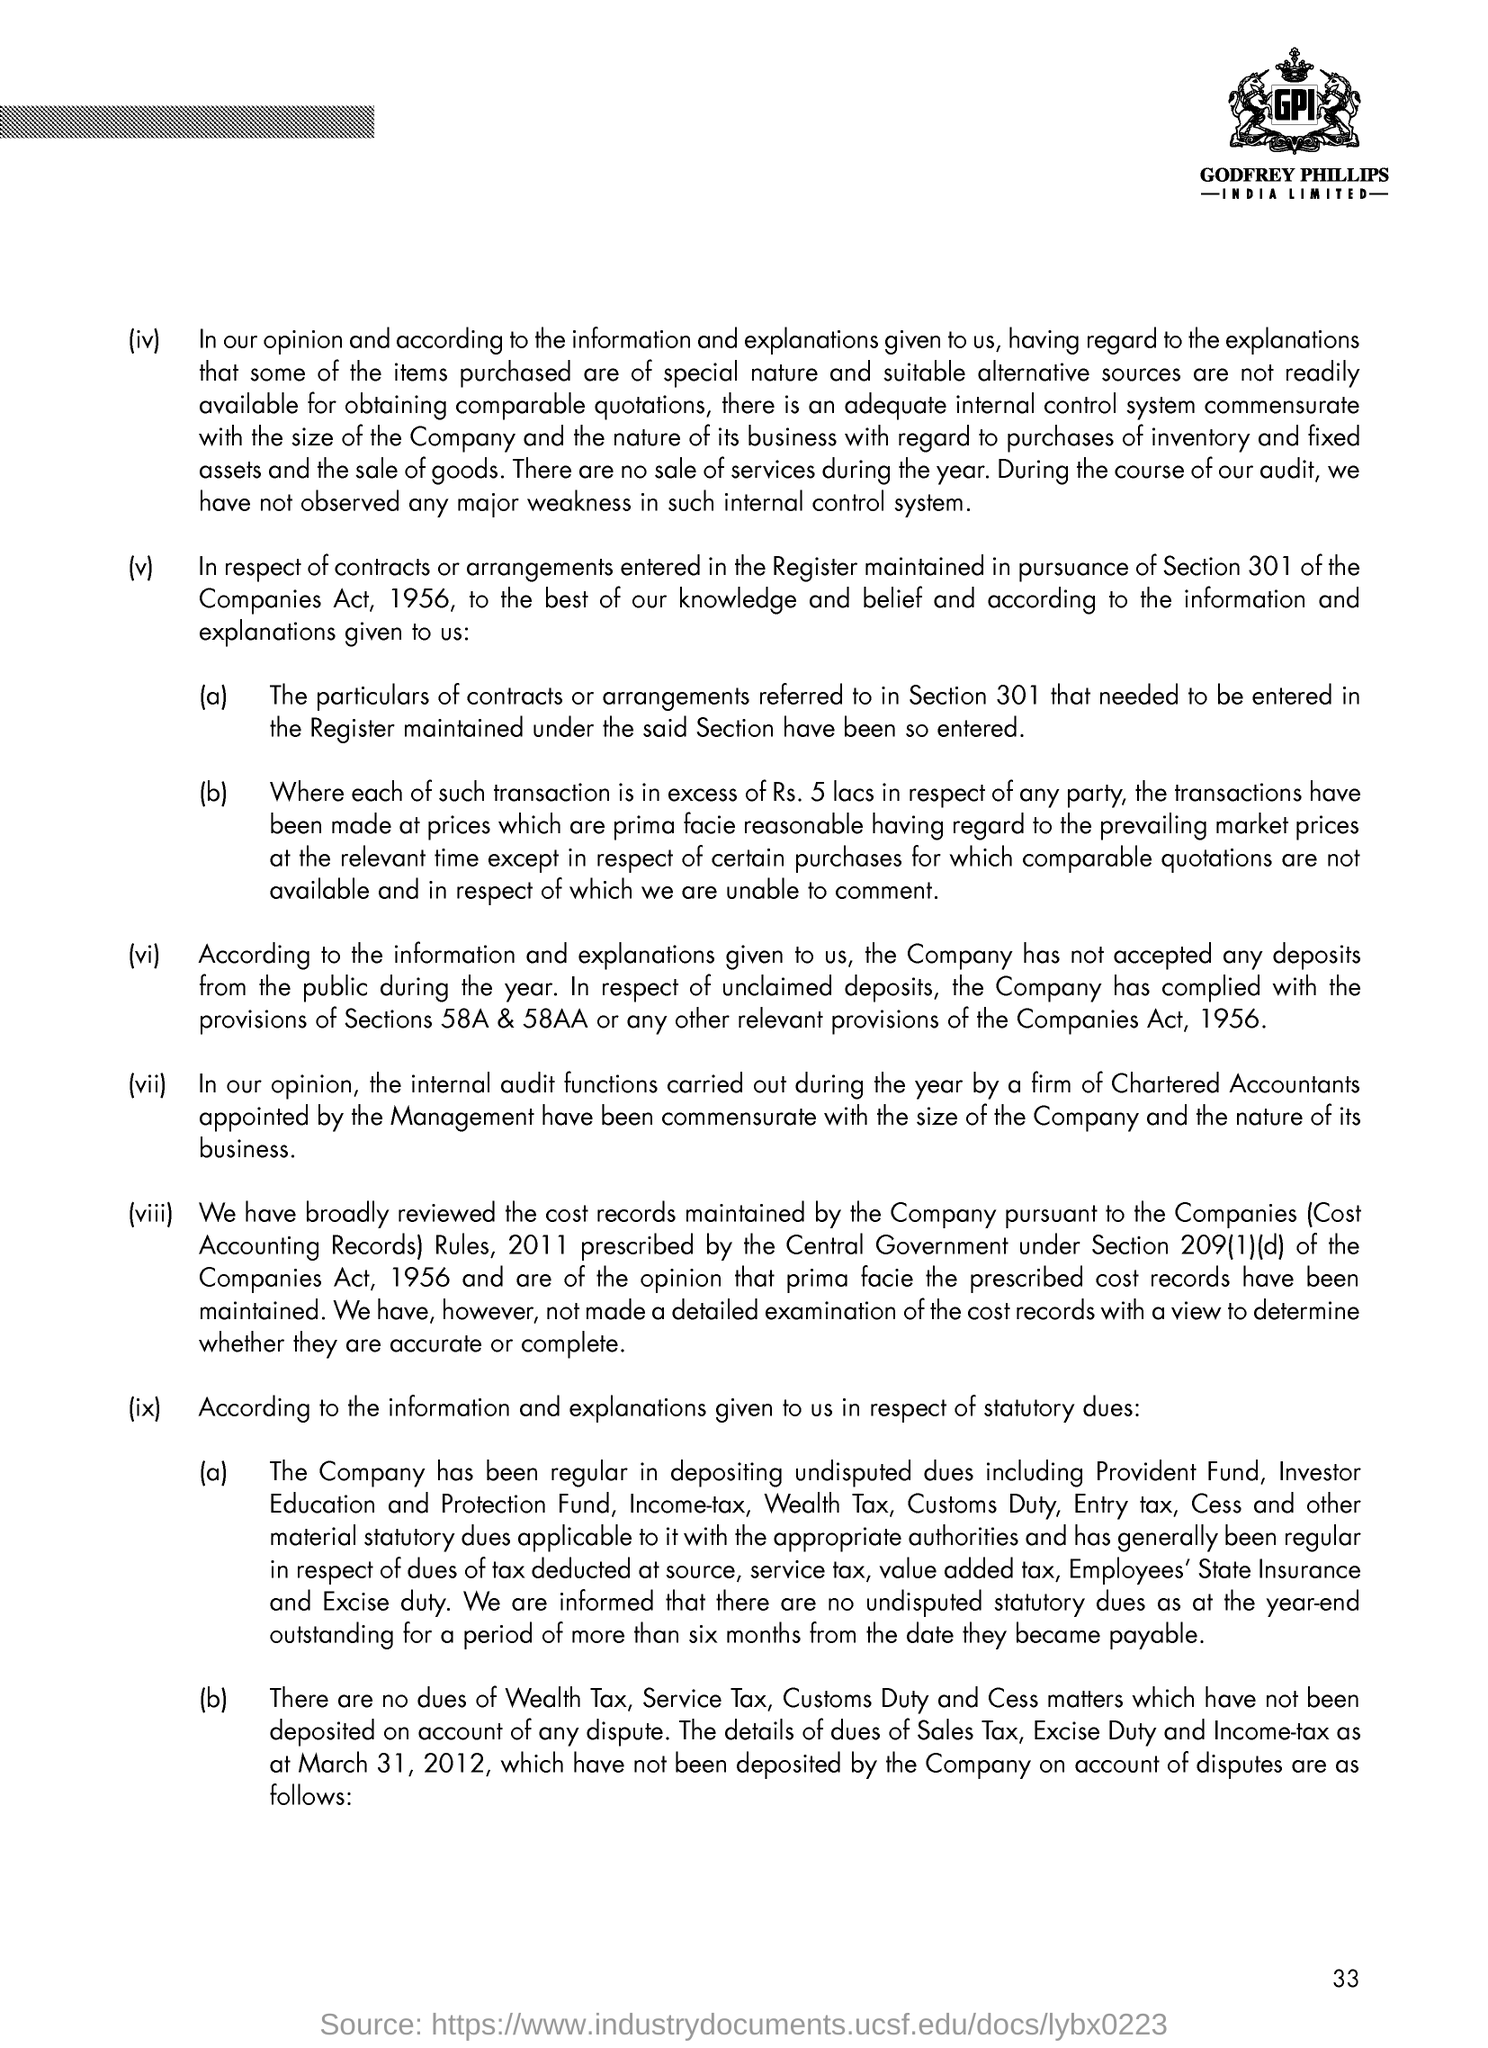What is the page no mentioned in this document?
Offer a terse response. 33. 